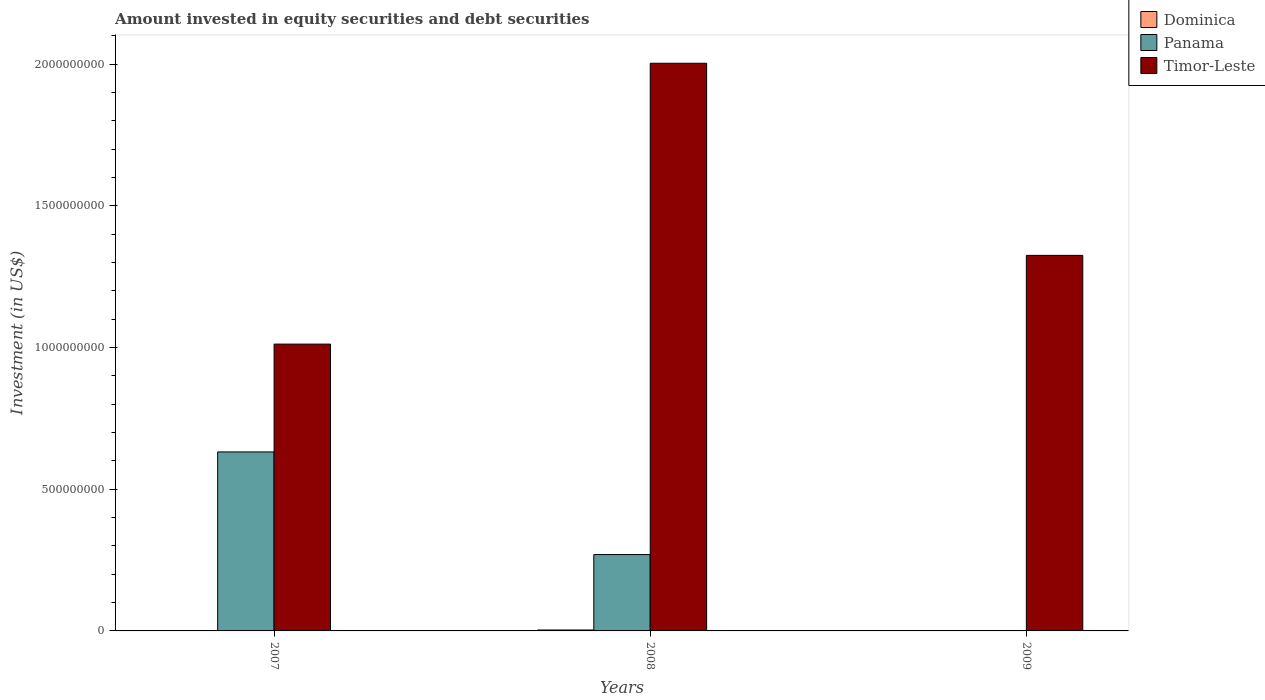How many different coloured bars are there?
Offer a very short reply. 3. Are the number of bars per tick equal to the number of legend labels?
Your response must be concise. No. How many bars are there on the 1st tick from the left?
Provide a short and direct response. 2. How many bars are there on the 3rd tick from the right?
Ensure brevity in your answer.  2. In how many cases, is the number of bars for a given year not equal to the number of legend labels?
Make the answer very short. 2. What is the amount invested in equity securities and debt securities in Panama in 2009?
Your answer should be compact. 0. Across all years, what is the maximum amount invested in equity securities and debt securities in Timor-Leste?
Give a very brief answer. 2.00e+09. Across all years, what is the minimum amount invested in equity securities and debt securities in Timor-Leste?
Give a very brief answer. 1.01e+09. What is the total amount invested in equity securities and debt securities in Panama in the graph?
Provide a short and direct response. 9.01e+08. What is the difference between the amount invested in equity securities and debt securities in Timor-Leste in 2007 and that in 2009?
Offer a very short reply. -3.13e+08. What is the difference between the amount invested in equity securities and debt securities in Panama in 2007 and the amount invested in equity securities and debt securities in Timor-Leste in 2009?
Your answer should be compact. -6.94e+08. What is the average amount invested in equity securities and debt securities in Timor-Leste per year?
Your answer should be compact. 1.45e+09. In the year 2008, what is the difference between the amount invested in equity securities and debt securities in Dominica and amount invested in equity securities and debt securities in Timor-Leste?
Make the answer very short. -2.00e+09. In how many years, is the amount invested in equity securities and debt securities in Dominica greater than 200000000 US$?
Your answer should be compact. 0. What is the ratio of the amount invested in equity securities and debt securities in Panama in 2007 to that in 2008?
Your answer should be very brief. 2.34. What is the difference between the highest and the second highest amount invested in equity securities and debt securities in Timor-Leste?
Your answer should be very brief. 6.78e+08. What is the difference between the highest and the lowest amount invested in equity securities and debt securities in Dominica?
Offer a terse response. 3.29e+06. Are all the bars in the graph horizontal?
Give a very brief answer. No. How many years are there in the graph?
Your response must be concise. 3. What is the difference between two consecutive major ticks on the Y-axis?
Give a very brief answer. 5.00e+08. Does the graph contain any zero values?
Give a very brief answer. Yes. Does the graph contain grids?
Offer a terse response. No. What is the title of the graph?
Ensure brevity in your answer.  Amount invested in equity securities and debt securities. What is the label or title of the Y-axis?
Offer a very short reply. Investment (in US$). What is the Investment (in US$) in Dominica in 2007?
Keep it short and to the point. 0. What is the Investment (in US$) of Panama in 2007?
Keep it short and to the point. 6.32e+08. What is the Investment (in US$) in Timor-Leste in 2007?
Give a very brief answer. 1.01e+09. What is the Investment (in US$) in Dominica in 2008?
Your answer should be compact. 3.29e+06. What is the Investment (in US$) in Panama in 2008?
Give a very brief answer. 2.70e+08. What is the Investment (in US$) in Timor-Leste in 2008?
Make the answer very short. 2.00e+09. What is the Investment (in US$) of Dominica in 2009?
Give a very brief answer. 0. What is the Investment (in US$) of Panama in 2009?
Give a very brief answer. 0. What is the Investment (in US$) of Timor-Leste in 2009?
Make the answer very short. 1.33e+09. Across all years, what is the maximum Investment (in US$) of Dominica?
Your answer should be compact. 3.29e+06. Across all years, what is the maximum Investment (in US$) of Panama?
Give a very brief answer. 6.32e+08. Across all years, what is the maximum Investment (in US$) in Timor-Leste?
Keep it short and to the point. 2.00e+09. Across all years, what is the minimum Investment (in US$) in Dominica?
Your answer should be compact. 0. Across all years, what is the minimum Investment (in US$) in Panama?
Your response must be concise. 0. Across all years, what is the minimum Investment (in US$) in Timor-Leste?
Give a very brief answer. 1.01e+09. What is the total Investment (in US$) in Dominica in the graph?
Offer a very short reply. 3.29e+06. What is the total Investment (in US$) of Panama in the graph?
Give a very brief answer. 9.01e+08. What is the total Investment (in US$) of Timor-Leste in the graph?
Your answer should be compact. 4.34e+09. What is the difference between the Investment (in US$) of Panama in 2007 and that in 2008?
Your response must be concise. 3.62e+08. What is the difference between the Investment (in US$) of Timor-Leste in 2007 and that in 2008?
Keep it short and to the point. -9.91e+08. What is the difference between the Investment (in US$) of Timor-Leste in 2007 and that in 2009?
Provide a short and direct response. -3.13e+08. What is the difference between the Investment (in US$) of Timor-Leste in 2008 and that in 2009?
Provide a succinct answer. 6.78e+08. What is the difference between the Investment (in US$) of Panama in 2007 and the Investment (in US$) of Timor-Leste in 2008?
Provide a succinct answer. -1.37e+09. What is the difference between the Investment (in US$) of Panama in 2007 and the Investment (in US$) of Timor-Leste in 2009?
Provide a short and direct response. -6.94e+08. What is the difference between the Investment (in US$) in Dominica in 2008 and the Investment (in US$) in Timor-Leste in 2009?
Your answer should be very brief. -1.32e+09. What is the difference between the Investment (in US$) in Panama in 2008 and the Investment (in US$) in Timor-Leste in 2009?
Ensure brevity in your answer.  -1.06e+09. What is the average Investment (in US$) in Dominica per year?
Provide a succinct answer. 1.10e+06. What is the average Investment (in US$) in Panama per year?
Make the answer very short. 3.00e+08. What is the average Investment (in US$) of Timor-Leste per year?
Your response must be concise. 1.45e+09. In the year 2007, what is the difference between the Investment (in US$) in Panama and Investment (in US$) in Timor-Leste?
Offer a terse response. -3.80e+08. In the year 2008, what is the difference between the Investment (in US$) of Dominica and Investment (in US$) of Panama?
Give a very brief answer. -2.66e+08. In the year 2008, what is the difference between the Investment (in US$) in Dominica and Investment (in US$) in Timor-Leste?
Your answer should be compact. -2.00e+09. In the year 2008, what is the difference between the Investment (in US$) in Panama and Investment (in US$) in Timor-Leste?
Your response must be concise. -1.73e+09. What is the ratio of the Investment (in US$) of Panama in 2007 to that in 2008?
Ensure brevity in your answer.  2.34. What is the ratio of the Investment (in US$) of Timor-Leste in 2007 to that in 2008?
Provide a short and direct response. 0.51. What is the ratio of the Investment (in US$) in Timor-Leste in 2007 to that in 2009?
Your answer should be compact. 0.76. What is the ratio of the Investment (in US$) of Timor-Leste in 2008 to that in 2009?
Keep it short and to the point. 1.51. What is the difference between the highest and the second highest Investment (in US$) of Timor-Leste?
Provide a succinct answer. 6.78e+08. What is the difference between the highest and the lowest Investment (in US$) of Dominica?
Give a very brief answer. 3.29e+06. What is the difference between the highest and the lowest Investment (in US$) of Panama?
Keep it short and to the point. 6.32e+08. What is the difference between the highest and the lowest Investment (in US$) in Timor-Leste?
Your answer should be compact. 9.91e+08. 